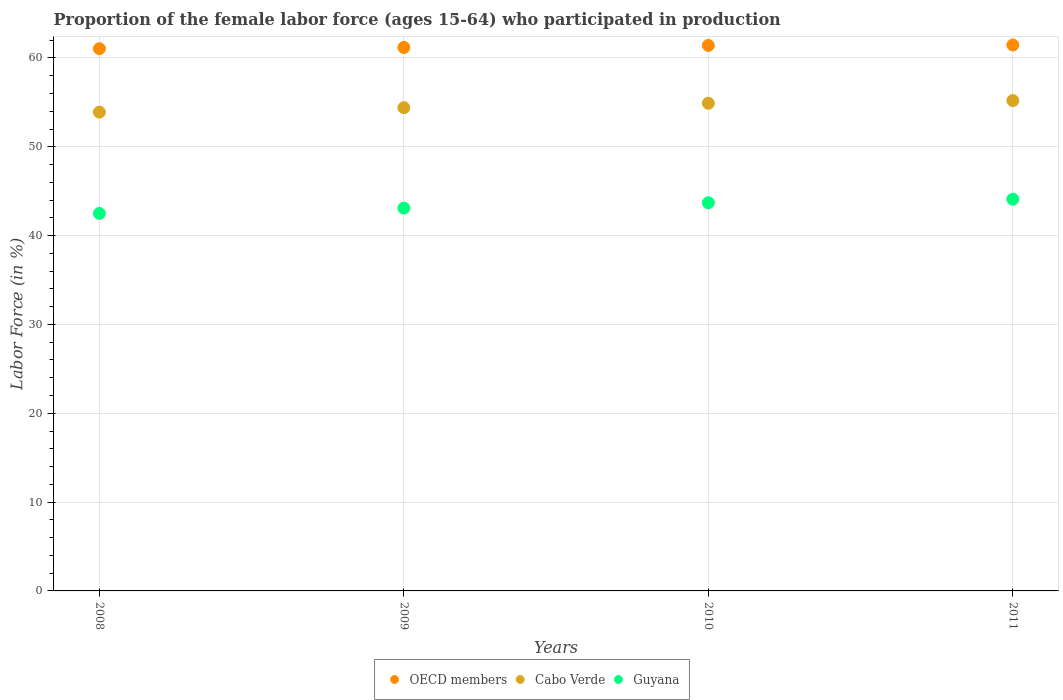What is the proportion of the female labor force who participated in production in Guyana in 2010?
Your response must be concise. 43.7. Across all years, what is the maximum proportion of the female labor force who participated in production in Cabo Verde?
Ensure brevity in your answer.  55.2. Across all years, what is the minimum proportion of the female labor force who participated in production in Cabo Verde?
Your response must be concise. 53.9. What is the total proportion of the female labor force who participated in production in OECD members in the graph?
Make the answer very short. 245.1. What is the difference between the proportion of the female labor force who participated in production in Cabo Verde in 2011 and the proportion of the female labor force who participated in production in OECD members in 2008?
Give a very brief answer. -5.84. What is the average proportion of the female labor force who participated in production in Cabo Verde per year?
Offer a very short reply. 54.6. In the year 2011, what is the difference between the proportion of the female labor force who participated in production in Guyana and proportion of the female labor force who participated in production in OECD members?
Give a very brief answer. -17.36. In how many years, is the proportion of the female labor force who participated in production in Guyana greater than 28 %?
Your response must be concise. 4. What is the ratio of the proportion of the female labor force who participated in production in Guyana in 2010 to that in 2011?
Offer a terse response. 0.99. Is the proportion of the female labor force who participated in production in Guyana in 2010 less than that in 2011?
Your answer should be very brief. Yes. Is the difference between the proportion of the female labor force who participated in production in Guyana in 2009 and 2011 greater than the difference between the proportion of the female labor force who participated in production in OECD members in 2009 and 2011?
Provide a short and direct response. No. What is the difference between the highest and the second highest proportion of the female labor force who participated in production in OECD members?
Offer a very short reply. 0.05. What is the difference between the highest and the lowest proportion of the female labor force who participated in production in Guyana?
Make the answer very short. 1.6. In how many years, is the proportion of the female labor force who participated in production in Guyana greater than the average proportion of the female labor force who participated in production in Guyana taken over all years?
Your answer should be compact. 2. Is the sum of the proportion of the female labor force who participated in production in Guyana in 2009 and 2011 greater than the maximum proportion of the female labor force who participated in production in Cabo Verde across all years?
Offer a terse response. Yes. Does the proportion of the female labor force who participated in production in Cabo Verde monotonically increase over the years?
Make the answer very short. Yes. Is the proportion of the female labor force who participated in production in Cabo Verde strictly less than the proportion of the female labor force who participated in production in Guyana over the years?
Ensure brevity in your answer.  No. How many dotlines are there?
Your answer should be compact. 3. How many years are there in the graph?
Give a very brief answer. 4. Are the values on the major ticks of Y-axis written in scientific E-notation?
Your response must be concise. No. Does the graph contain grids?
Your answer should be compact. Yes. What is the title of the graph?
Your answer should be compact. Proportion of the female labor force (ages 15-64) who participated in production. Does "Caribbean small states" appear as one of the legend labels in the graph?
Keep it short and to the point. No. What is the label or title of the X-axis?
Keep it short and to the point. Years. What is the label or title of the Y-axis?
Give a very brief answer. Labor Force (in %). What is the Labor Force (in %) of OECD members in 2008?
Provide a short and direct response. 61.04. What is the Labor Force (in %) of Cabo Verde in 2008?
Provide a succinct answer. 53.9. What is the Labor Force (in %) in Guyana in 2008?
Your answer should be very brief. 42.5. What is the Labor Force (in %) of OECD members in 2009?
Make the answer very short. 61.18. What is the Labor Force (in %) in Cabo Verde in 2009?
Provide a short and direct response. 54.4. What is the Labor Force (in %) in Guyana in 2009?
Provide a succinct answer. 43.1. What is the Labor Force (in %) of OECD members in 2010?
Provide a short and direct response. 61.41. What is the Labor Force (in %) of Cabo Verde in 2010?
Provide a succinct answer. 54.9. What is the Labor Force (in %) in Guyana in 2010?
Provide a succinct answer. 43.7. What is the Labor Force (in %) of OECD members in 2011?
Your response must be concise. 61.46. What is the Labor Force (in %) of Cabo Verde in 2011?
Keep it short and to the point. 55.2. What is the Labor Force (in %) of Guyana in 2011?
Your answer should be very brief. 44.1. Across all years, what is the maximum Labor Force (in %) of OECD members?
Give a very brief answer. 61.46. Across all years, what is the maximum Labor Force (in %) of Cabo Verde?
Give a very brief answer. 55.2. Across all years, what is the maximum Labor Force (in %) in Guyana?
Your answer should be very brief. 44.1. Across all years, what is the minimum Labor Force (in %) in OECD members?
Give a very brief answer. 61.04. Across all years, what is the minimum Labor Force (in %) in Cabo Verde?
Your answer should be very brief. 53.9. Across all years, what is the minimum Labor Force (in %) in Guyana?
Your answer should be compact. 42.5. What is the total Labor Force (in %) of OECD members in the graph?
Provide a short and direct response. 245.1. What is the total Labor Force (in %) of Cabo Verde in the graph?
Give a very brief answer. 218.4. What is the total Labor Force (in %) of Guyana in the graph?
Your answer should be very brief. 173.4. What is the difference between the Labor Force (in %) in OECD members in 2008 and that in 2009?
Keep it short and to the point. -0.14. What is the difference between the Labor Force (in %) of OECD members in 2008 and that in 2010?
Give a very brief answer. -0.37. What is the difference between the Labor Force (in %) of Cabo Verde in 2008 and that in 2010?
Keep it short and to the point. -1. What is the difference between the Labor Force (in %) of OECD members in 2008 and that in 2011?
Ensure brevity in your answer.  -0.42. What is the difference between the Labor Force (in %) in Guyana in 2008 and that in 2011?
Make the answer very short. -1.6. What is the difference between the Labor Force (in %) in OECD members in 2009 and that in 2010?
Your response must be concise. -0.23. What is the difference between the Labor Force (in %) in Cabo Verde in 2009 and that in 2010?
Ensure brevity in your answer.  -0.5. What is the difference between the Labor Force (in %) of Guyana in 2009 and that in 2010?
Your response must be concise. -0.6. What is the difference between the Labor Force (in %) of OECD members in 2009 and that in 2011?
Your answer should be very brief. -0.27. What is the difference between the Labor Force (in %) in OECD members in 2010 and that in 2011?
Offer a very short reply. -0.05. What is the difference between the Labor Force (in %) of OECD members in 2008 and the Labor Force (in %) of Cabo Verde in 2009?
Your answer should be compact. 6.64. What is the difference between the Labor Force (in %) of OECD members in 2008 and the Labor Force (in %) of Guyana in 2009?
Ensure brevity in your answer.  17.94. What is the difference between the Labor Force (in %) of Cabo Verde in 2008 and the Labor Force (in %) of Guyana in 2009?
Offer a very short reply. 10.8. What is the difference between the Labor Force (in %) in OECD members in 2008 and the Labor Force (in %) in Cabo Verde in 2010?
Your response must be concise. 6.14. What is the difference between the Labor Force (in %) of OECD members in 2008 and the Labor Force (in %) of Guyana in 2010?
Your response must be concise. 17.34. What is the difference between the Labor Force (in %) in OECD members in 2008 and the Labor Force (in %) in Cabo Verde in 2011?
Your response must be concise. 5.84. What is the difference between the Labor Force (in %) of OECD members in 2008 and the Labor Force (in %) of Guyana in 2011?
Offer a terse response. 16.94. What is the difference between the Labor Force (in %) in Cabo Verde in 2008 and the Labor Force (in %) in Guyana in 2011?
Offer a terse response. 9.8. What is the difference between the Labor Force (in %) in OECD members in 2009 and the Labor Force (in %) in Cabo Verde in 2010?
Give a very brief answer. 6.28. What is the difference between the Labor Force (in %) in OECD members in 2009 and the Labor Force (in %) in Guyana in 2010?
Offer a terse response. 17.48. What is the difference between the Labor Force (in %) in Cabo Verde in 2009 and the Labor Force (in %) in Guyana in 2010?
Ensure brevity in your answer.  10.7. What is the difference between the Labor Force (in %) in OECD members in 2009 and the Labor Force (in %) in Cabo Verde in 2011?
Provide a succinct answer. 5.98. What is the difference between the Labor Force (in %) in OECD members in 2009 and the Labor Force (in %) in Guyana in 2011?
Keep it short and to the point. 17.08. What is the difference between the Labor Force (in %) of Cabo Verde in 2009 and the Labor Force (in %) of Guyana in 2011?
Offer a very short reply. 10.3. What is the difference between the Labor Force (in %) of OECD members in 2010 and the Labor Force (in %) of Cabo Verde in 2011?
Your answer should be very brief. 6.21. What is the difference between the Labor Force (in %) in OECD members in 2010 and the Labor Force (in %) in Guyana in 2011?
Provide a short and direct response. 17.31. What is the difference between the Labor Force (in %) in Cabo Verde in 2010 and the Labor Force (in %) in Guyana in 2011?
Offer a very short reply. 10.8. What is the average Labor Force (in %) of OECD members per year?
Your answer should be compact. 61.27. What is the average Labor Force (in %) in Cabo Verde per year?
Provide a succinct answer. 54.6. What is the average Labor Force (in %) of Guyana per year?
Keep it short and to the point. 43.35. In the year 2008, what is the difference between the Labor Force (in %) of OECD members and Labor Force (in %) of Cabo Verde?
Keep it short and to the point. 7.14. In the year 2008, what is the difference between the Labor Force (in %) of OECD members and Labor Force (in %) of Guyana?
Your answer should be compact. 18.54. In the year 2009, what is the difference between the Labor Force (in %) of OECD members and Labor Force (in %) of Cabo Verde?
Offer a very short reply. 6.78. In the year 2009, what is the difference between the Labor Force (in %) of OECD members and Labor Force (in %) of Guyana?
Provide a short and direct response. 18.08. In the year 2010, what is the difference between the Labor Force (in %) of OECD members and Labor Force (in %) of Cabo Verde?
Offer a terse response. 6.51. In the year 2010, what is the difference between the Labor Force (in %) in OECD members and Labor Force (in %) in Guyana?
Your response must be concise. 17.71. In the year 2011, what is the difference between the Labor Force (in %) of OECD members and Labor Force (in %) of Cabo Verde?
Your answer should be very brief. 6.26. In the year 2011, what is the difference between the Labor Force (in %) in OECD members and Labor Force (in %) in Guyana?
Your answer should be compact. 17.36. In the year 2011, what is the difference between the Labor Force (in %) of Cabo Verde and Labor Force (in %) of Guyana?
Your answer should be very brief. 11.1. What is the ratio of the Labor Force (in %) of Cabo Verde in 2008 to that in 2009?
Offer a terse response. 0.99. What is the ratio of the Labor Force (in %) of Guyana in 2008 to that in 2009?
Keep it short and to the point. 0.99. What is the ratio of the Labor Force (in %) of OECD members in 2008 to that in 2010?
Your answer should be compact. 0.99. What is the ratio of the Labor Force (in %) in Cabo Verde in 2008 to that in 2010?
Your answer should be compact. 0.98. What is the ratio of the Labor Force (in %) of Guyana in 2008 to that in 2010?
Your answer should be compact. 0.97. What is the ratio of the Labor Force (in %) of Cabo Verde in 2008 to that in 2011?
Your response must be concise. 0.98. What is the ratio of the Labor Force (in %) of Guyana in 2008 to that in 2011?
Your response must be concise. 0.96. What is the ratio of the Labor Force (in %) in OECD members in 2009 to that in 2010?
Offer a very short reply. 1. What is the ratio of the Labor Force (in %) of Cabo Verde in 2009 to that in 2010?
Ensure brevity in your answer.  0.99. What is the ratio of the Labor Force (in %) in Guyana in 2009 to that in 2010?
Provide a short and direct response. 0.99. What is the ratio of the Labor Force (in %) of Cabo Verde in 2009 to that in 2011?
Give a very brief answer. 0.99. What is the ratio of the Labor Force (in %) of Guyana in 2009 to that in 2011?
Offer a very short reply. 0.98. What is the ratio of the Labor Force (in %) in Cabo Verde in 2010 to that in 2011?
Keep it short and to the point. 0.99. What is the ratio of the Labor Force (in %) in Guyana in 2010 to that in 2011?
Provide a short and direct response. 0.99. What is the difference between the highest and the second highest Labor Force (in %) in OECD members?
Offer a terse response. 0.05. What is the difference between the highest and the second highest Labor Force (in %) in Cabo Verde?
Offer a very short reply. 0.3. What is the difference between the highest and the lowest Labor Force (in %) in OECD members?
Provide a short and direct response. 0.42. What is the difference between the highest and the lowest Labor Force (in %) in Guyana?
Provide a succinct answer. 1.6. 